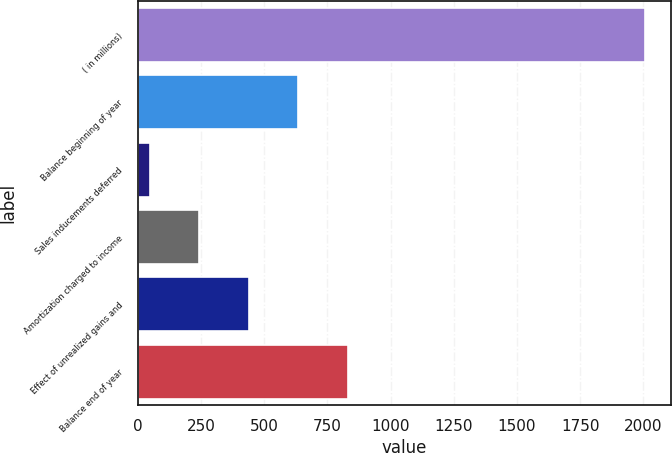Convert chart. <chart><loc_0><loc_0><loc_500><loc_500><bar_chart><fcel>( in millions)<fcel>Balance beginning of year<fcel>Sales inducements deferred<fcel>Amortization charged to income<fcel>Effect of unrealized gains and<fcel>Balance end of year<nl><fcel>2008<fcel>635.3<fcel>47<fcel>243.1<fcel>439.2<fcel>831.4<nl></chart> 